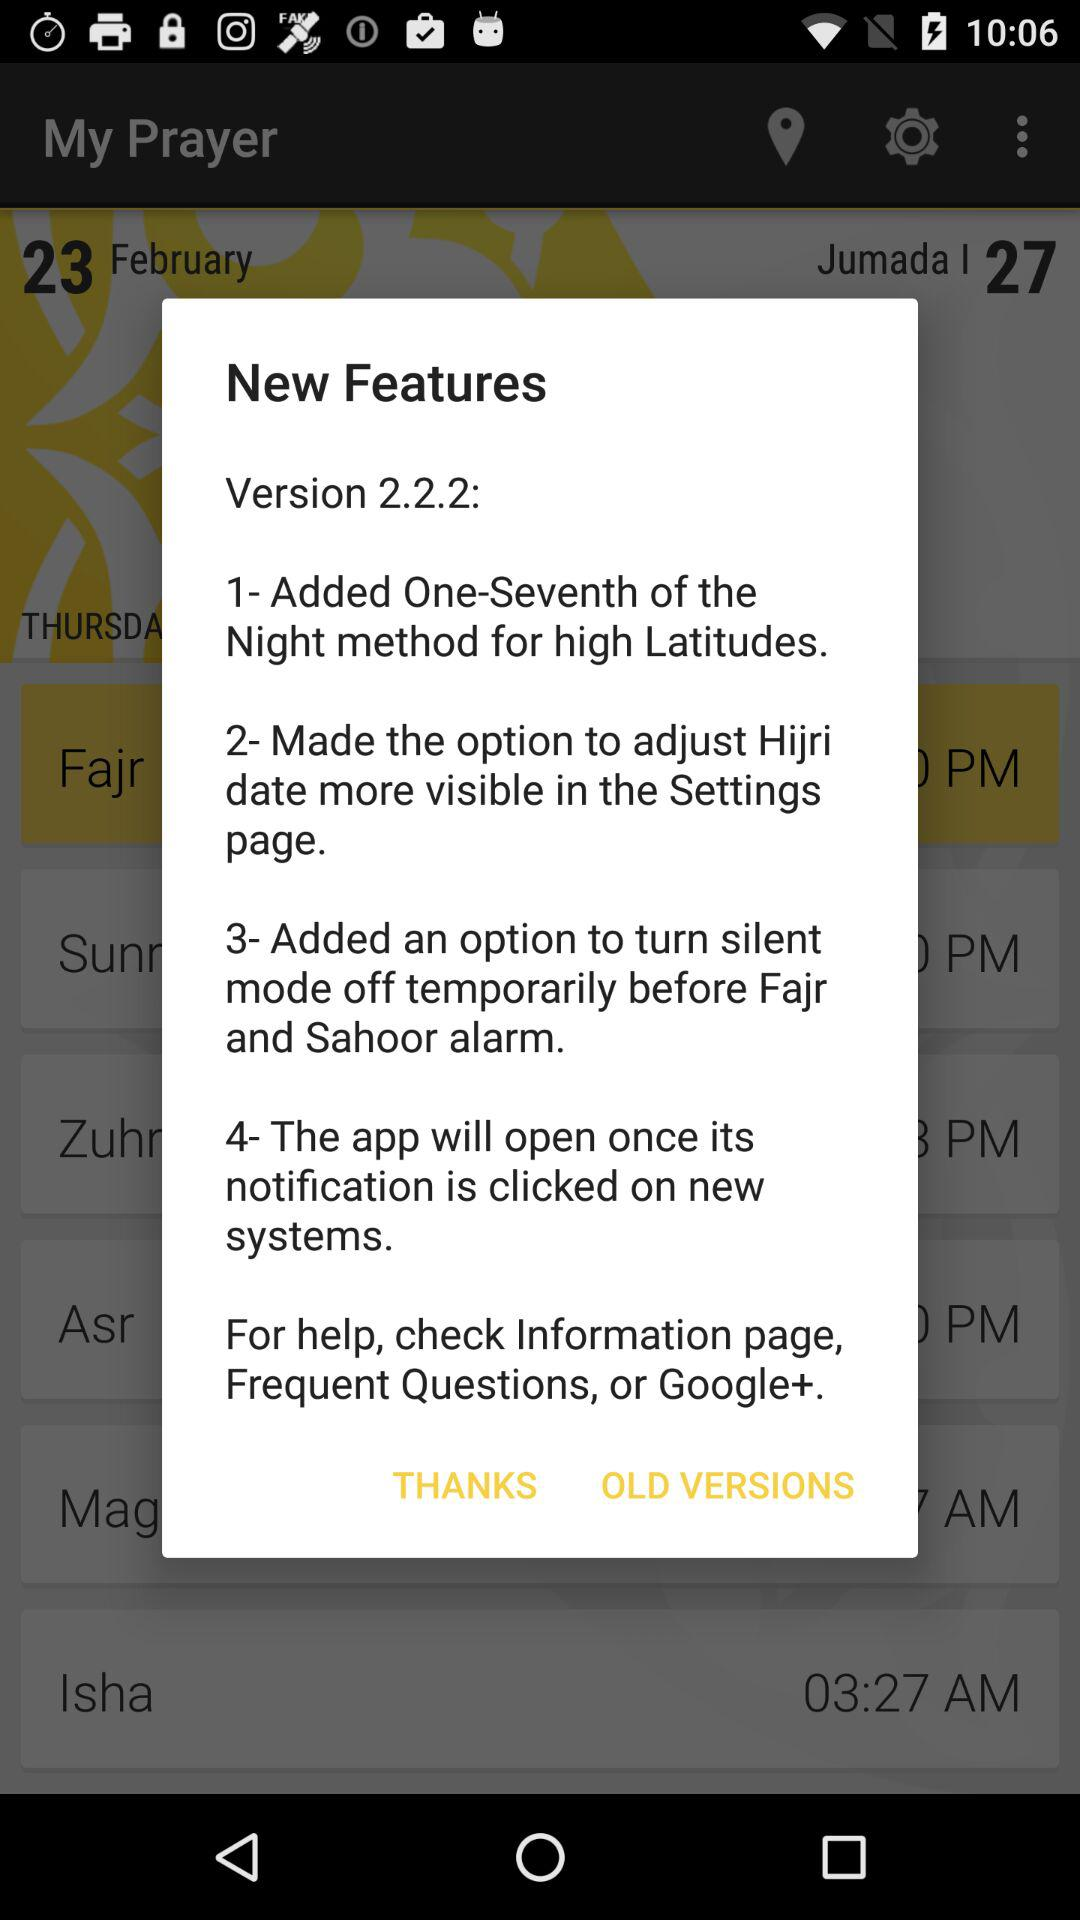What is the version? The version is 2.2.2. 